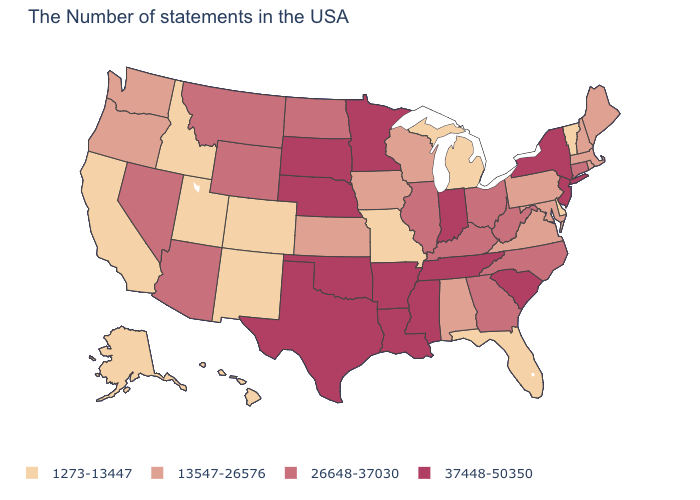What is the value of Arkansas?
Give a very brief answer. 37448-50350. Which states hav the highest value in the West?
Be succinct. Wyoming, Montana, Arizona, Nevada. Does Wyoming have the highest value in the West?
Be succinct. Yes. Does Oklahoma have a higher value than Pennsylvania?
Short answer required. Yes. Does Vermont have the lowest value in the Northeast?
Keep it brief. Yes. Which states have the lowest value in the South?
Quick response, please. Delaware, Florida. Name the states that have a value in the range 37448-50350?
Concise answer only. New York, New Jersey, South Carolina, Indiana, Tennessee, Mississippi, Louisiana, Arkansas, Minnesota, Nebraska, Oklahoma, Texas, South Dakota. What is the highest value in the USA?
Give a very brief answer. 37448-50350. Does Iowa have a higher value than Minnesota?
Keep it brief. No. Name the states that have a value in the range 1273-13447?
Give a very brief answer. Vermont, Delaware, Florida, Michigan, Missouri, Colorado, New Mexico, Utah, Idaho, California, Alaska, Hawaii. Name the states that have a value in the range 1273-13447?
Write a very short answer. Vermont, Delaware, Florida, Michigan, Missouri, Colorado, New Mexico, Utah, Idaho, California, Alaska, Hawaii. What is the value of Idaho?
Give a very brief answer. 1273-13447. What is the lowest value in the South?
Give a very brief answer. 1273-13447. Does New Jersey have the lowest value in the USA?
Answer briefly. No. Among the states that border West Virginia , does Virginia have the highest value?
Short answer required. No. 